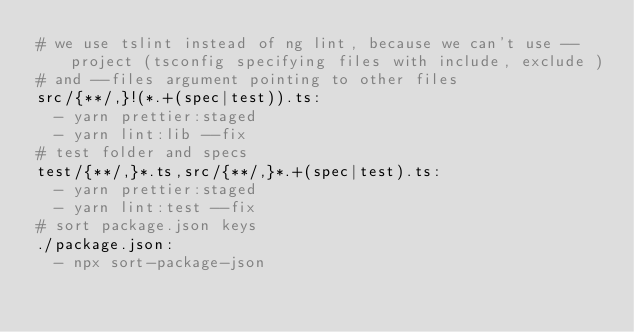<code> <loc_0><loc_0><loc_500><loc_500><_YAML_># we use tslint instead of ng lint, because we can't use --project (tsconfig specifying files with include, exclude )
# and --files argument pointing to other files
src/{**/,}!(*.+(spec|test)).ts:
  - yarn prettier:staged
  - yarn lint:lib --fix
# test folder and specs
test/{**/,}*.ts,src/{**/,}*.+(spec|test).ts:
  - yarn prettier:staged
  - yarn lint:test --fix
# sort package.json keys
./package.json:
  - npx sort-package-json
</code> 